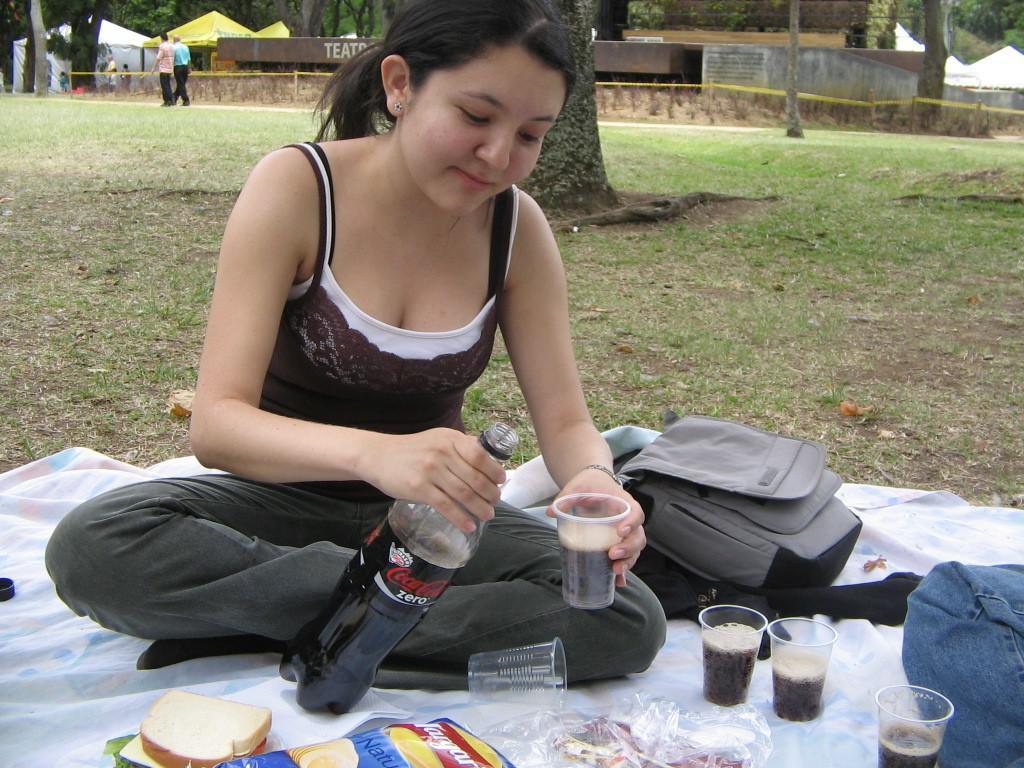Describe this image in one or two sentences. There is a woman holding a bottle and a glass with her hands and she is smiling. Here we can see a cloth, glasses, bag, and food. This is grass. In the background we can see trees, houses, and few persons. 